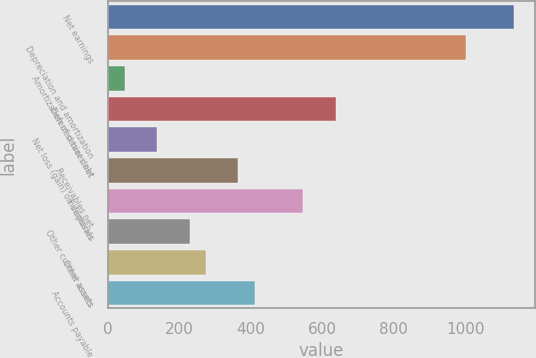<chart> <loc_0><loc_0><loc_500><loc_500><bar_chart><fcel>Net earnings<fcel>Depreciation and amortization<fcel>Amortization of senior debt<fcel>Deferred taxes net<fcel>Net loss (gain) on disposals<fcel>Receivables net<fcel>Inventories<fcel>Other current assets<fcel>Other assets<fcel>Accounts payable<nl><fcel>1136.2<fcel>1000.12<fcel>47.56<fcel>637.24<fcel>138.28<fcel>365.08<fcel>546.52<fcel>229<fcel>274.36<fcel>410.44<nl></chart> 